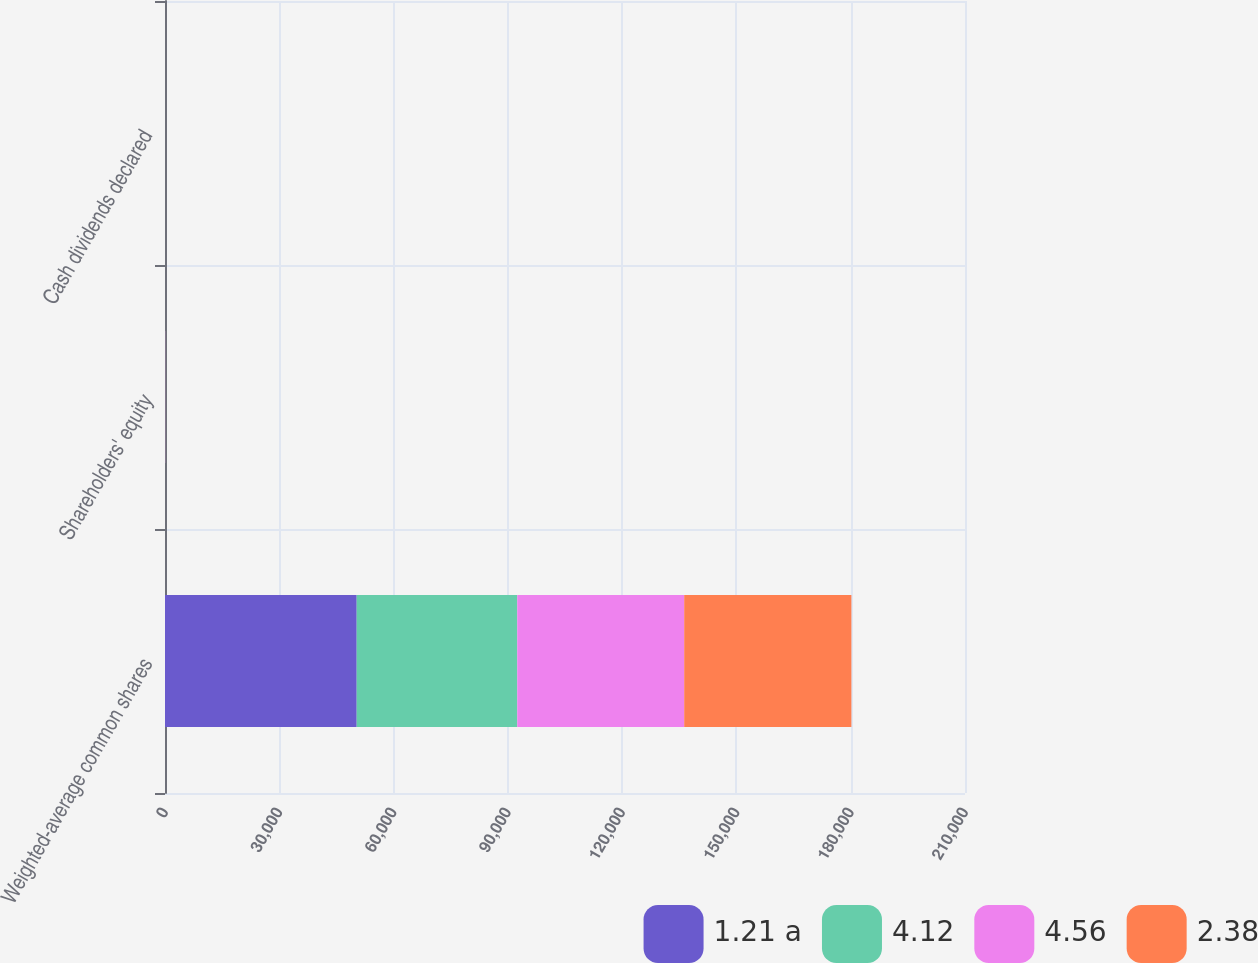Convert chart to OTSL. <chart><loc_0><loc_0><loc_500><loc_500><stacked_bar_chart><ecel><fcel>Weighted-average common shares<fcel>Shareholders' equity<fcel>Cash dividends declared<nl><fcel>1.21 a<fcel>50323<fcel>38.43<fcel>0.16<nl><fcel>4.12<fcel>42146<fcel>30.32<fcel>0.16<nl><fcel>4.56<fcel>43823<fcel>25.27<fcel>0.16<nl><fcel>2.38<fcel>43884<fcel>21.35<fcel>0.15<nl></chart> 